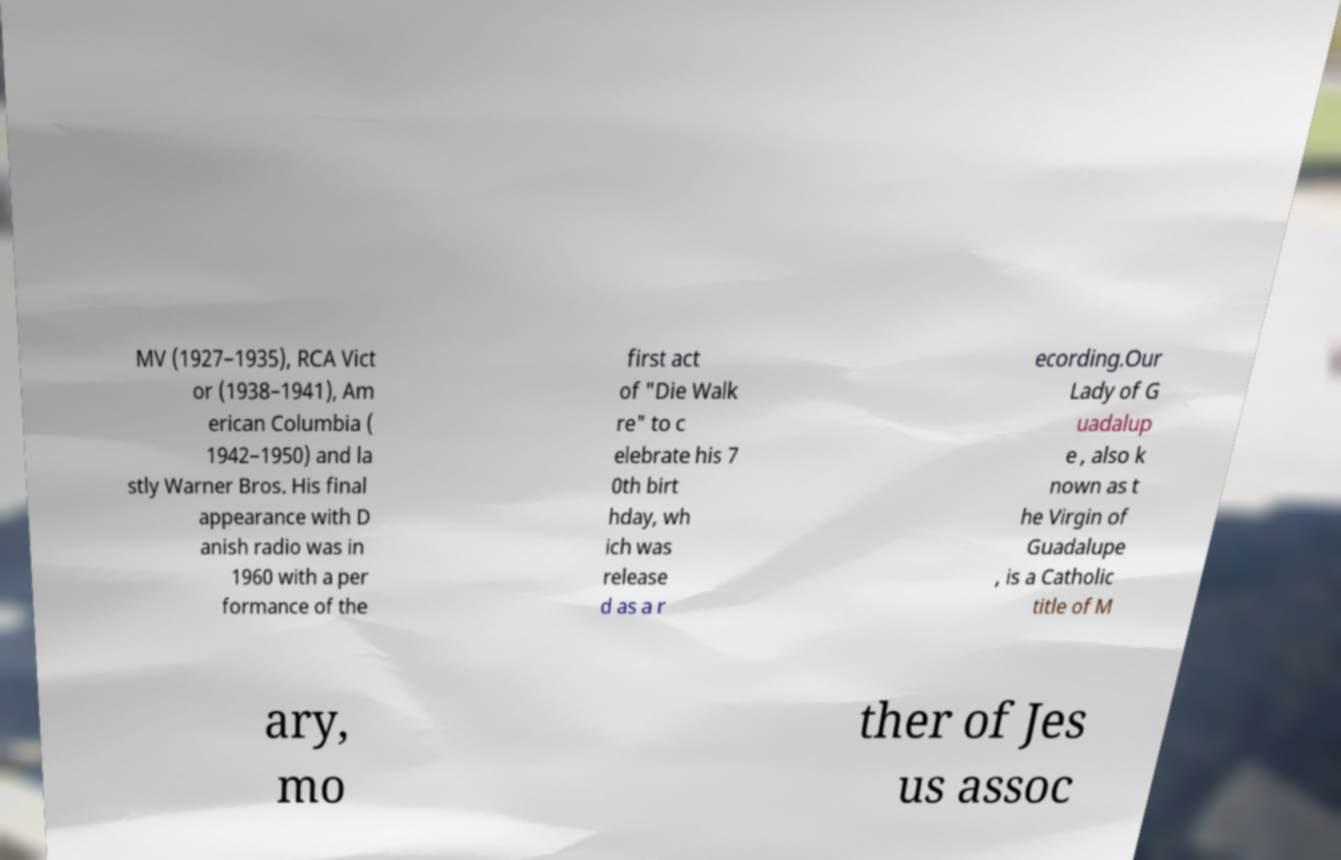I need the written content from this picture converted into text. Can you do that? MV (1927–1935), RCA Vict or (1938–1941), Am erican Columbia ( 1942–1950) and la stly Warner Bros. His final appearance with D anish radio was in 1960 with a per formance of the first act of "Die Walk re" to c elebrate his 7 0th birt hday, wh ich was release d as a r ecording.Our Lady of G uadalup e , also k nown as t he Virgin of Guadalupe , is a Catholic title of M ary, mo ther of Jes us assoc 